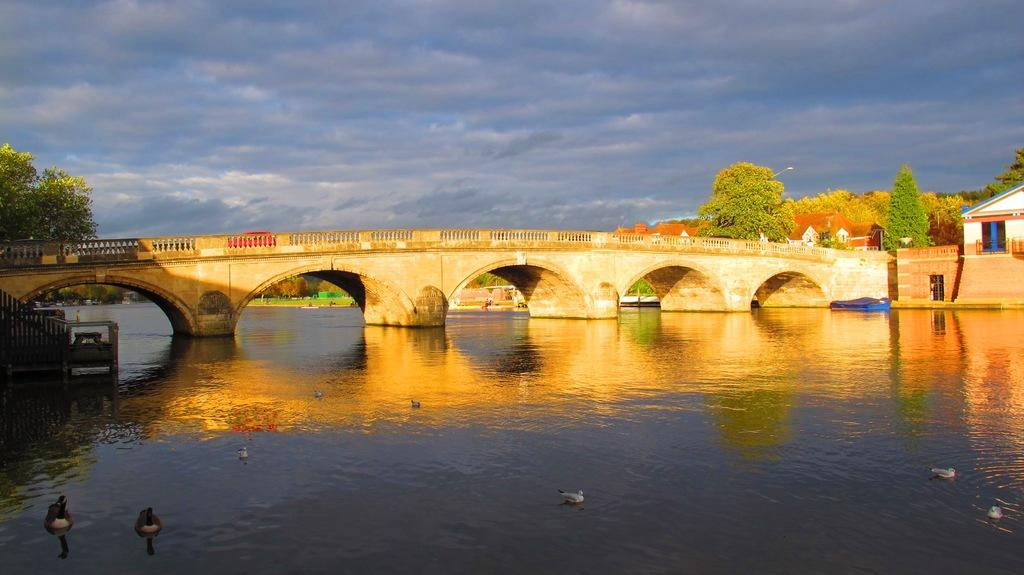What type of animals can be seen in the image? There are birds and swans in the image. Where are the birds and swans located? They are on a lake in the image. What can be seen in the background of the image? There is a bridge, trees, houses, and the sky visible in the background of the image. What is the wealth of the minister in the image? There is no minister present in the image, so it is not possible to determine their wealth. 